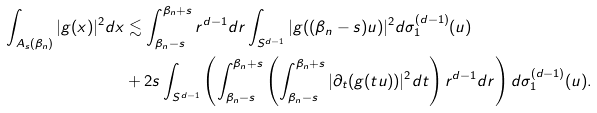<formula> <loc_0><loc_0><loc_500><loc_500>\int _ { A _ { s } ( \beta _ { n } ) } | g ( x ) | ^ { 2 } d x & \lesssim \int _ { \beta _ { n } - s } ^ { \beta _ { n } + s } r ^ { d - 1 } d r \int _ { S ^ { d - 1 } } | g ( ( \beta _ { n } - s ) u ) | ^ { 2 } d \sigma ^ { ( d - 1 ) } _ { 1 } ( u ) \\ & + 2 s \int _ { S ^ { d - 1 } } \left ( \int _ { \beta _ { n } - s } ^ { \beta _ { n } + s } \left ( \int _ { \beta _ { n } - s } ^ { \beta _ { n } + s } | \partial _ { t } ( g ( t u ) ) | ^ { 2 } d t \right ) r ^ { d - 1 } d r \right ) d \sigma _ { 1 } ^ { ( d - 1 ) } ( u ) .</formula> 